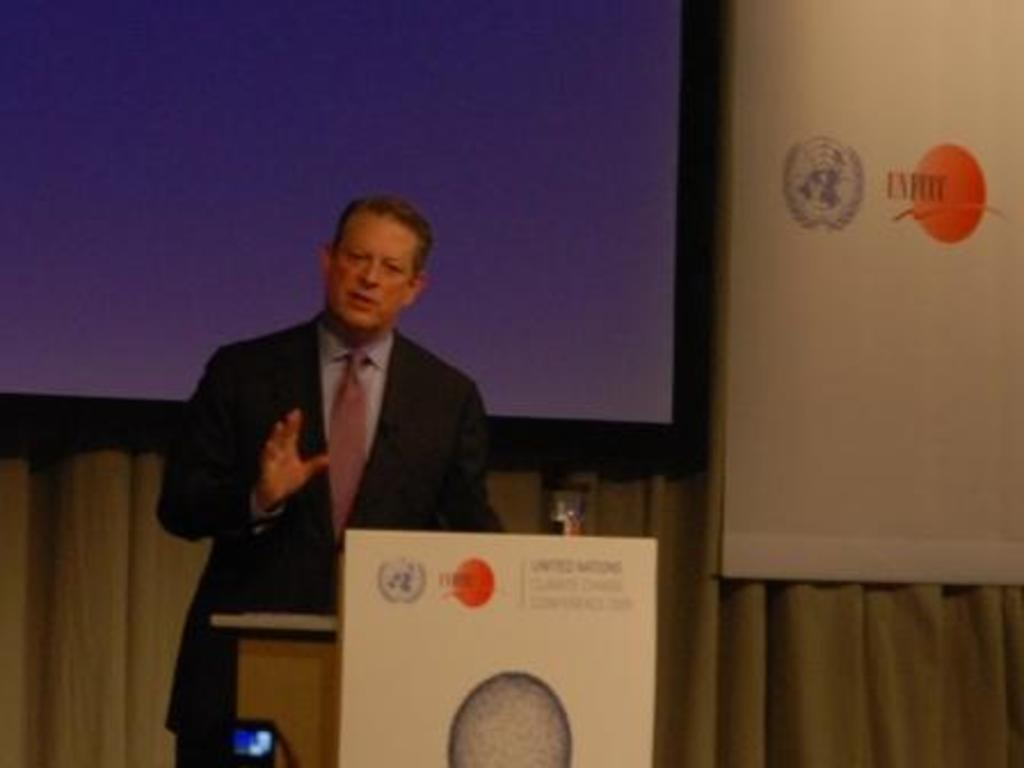What is the person in the image doing? The person is standing in front of a desk. What object is visible in the foreground of the image? A microphone is present in the foreground area of the image. What can be seen in the background of the image? There is a screen, a poster, and a curtain in the background. What type of cushion is placed on top of the screen in the image? There is no cushion present on top of the screen in the image. 